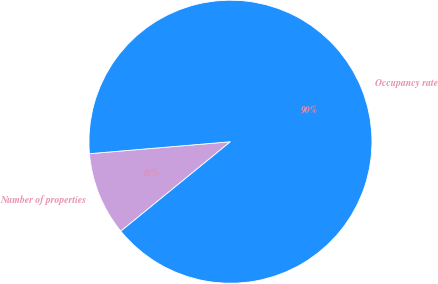<chart> <loc_0><loc_0><loc_500><loc_500><pie_chart><fcel>Number of properties<fcel>Occupancy rate<nl><fcel>9.55%<fcel>90.45%<nl></chart> 